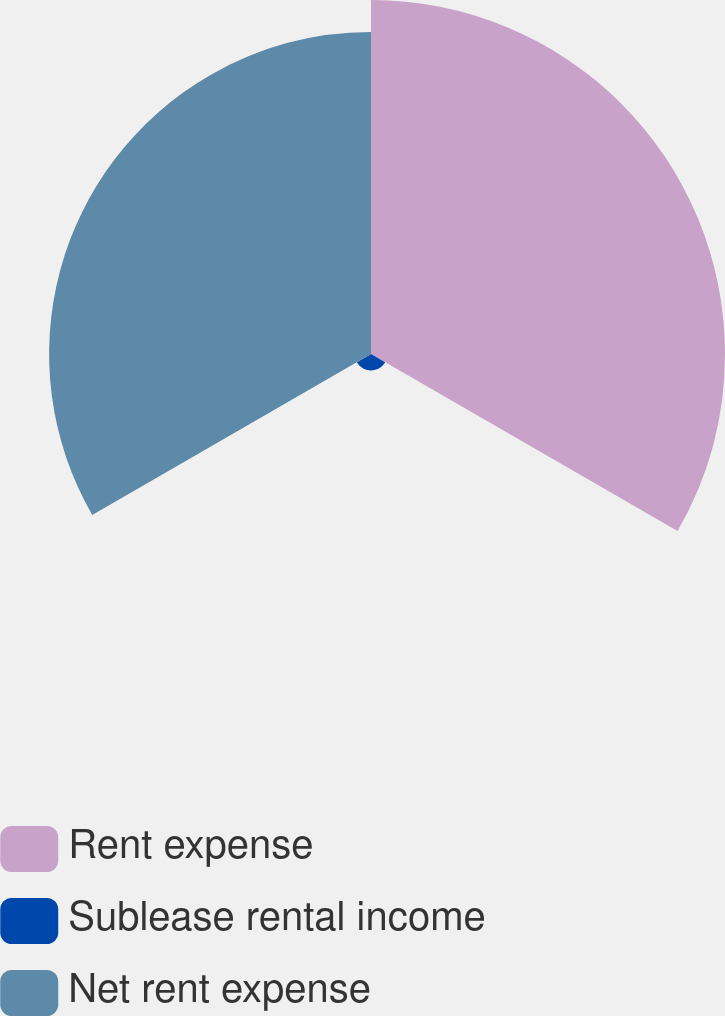Convert chart to OTSL. <chart><loc_0><loc_0><loc_500><loc_500><pie_chart><fcel>Rent expense<fcel>Sublease rental income<fcel>Net rent expense<nl><fcel>51.14%<fcel>2.36%<fcel>46.5%<nl></chart> 